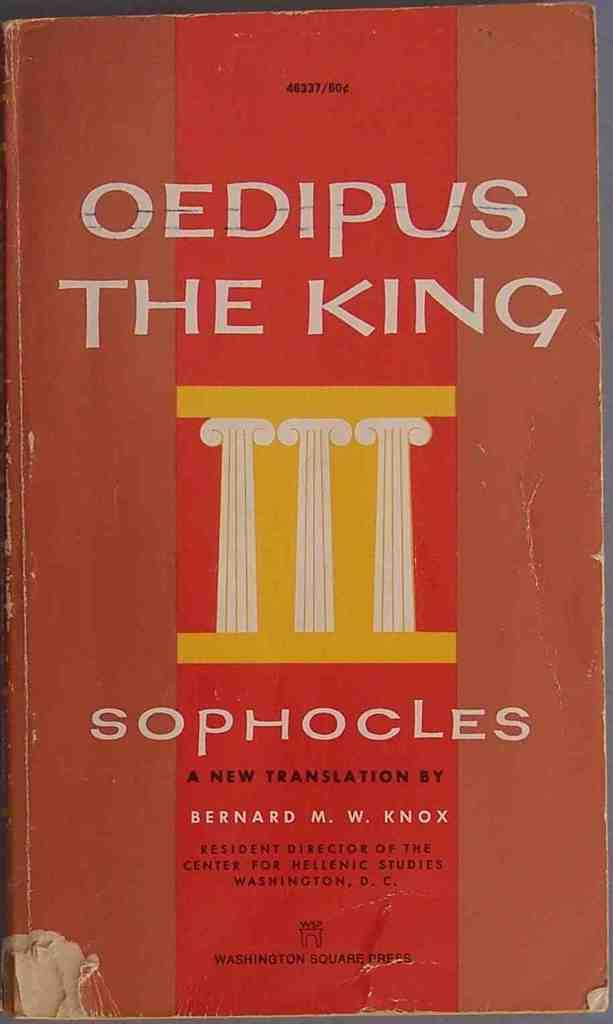<image>
Describe the image concisely. a book that says 'oedipus the king sophocles' at the top of it 